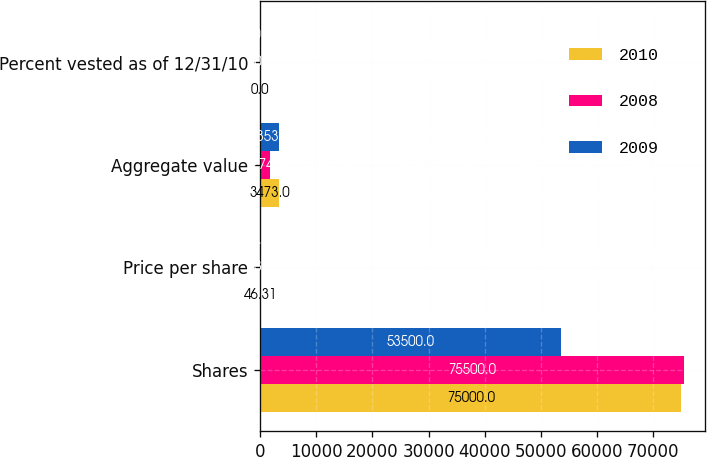Convert chart. <chart><loc_0><loc_0><loc_500><loc_500><stacked_bar_chart><ecel><fcel>Shares<fcel>Price per share<fcel>Aggregate value<fcel>Percent vested as of 12/31/10<nl><fcel>2010<fcel>75000<fcel>46.31<fcel>3473<fcel>0<nl><fcel>2008<fcel>75500<fcel>23.5<fcel>1774<fcel>20<nl><fcel>2009<fcel>53500<fcel>62.68<fcel>3353<fcel>40<nl></chart> 